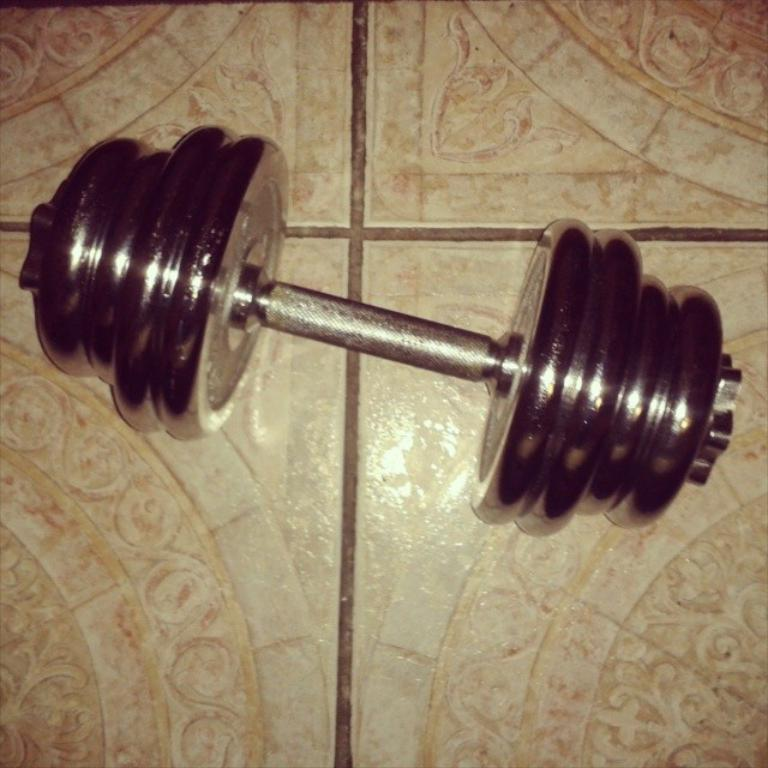What is the main object in the image? There is a barbell in the image. Where is the barbell located in the image? The barbell is in the center of the image. What is the position of the barbell in relation to the ground? The barbell is on the floor. How many geese are flying over the barbell in the image? There are no geese present in the image; it only features a barbell on the floor. 